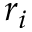<formula> <loc_0><loc_0><loc_500><loc_500>r _ { i }</formula> 